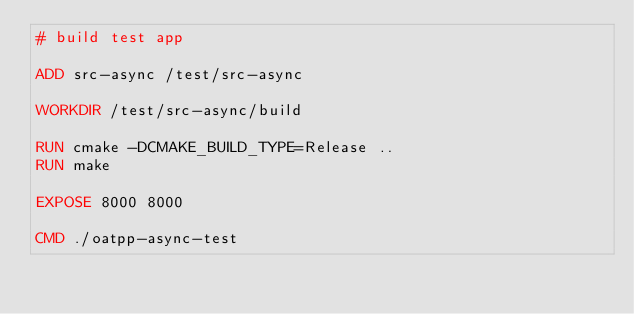<code> <loc_0><loc_0><loc_500><loc_500><_Dockerfile_># build test app

ADD src-async /test/src-async

WORKDIR /test/src-async/build

RUN cmake -DCMAKE_BUILD_TYPE=Release ..
RUN make

EXPOSE 8000 8000

CMD ./oatpp-async-test
</code> 